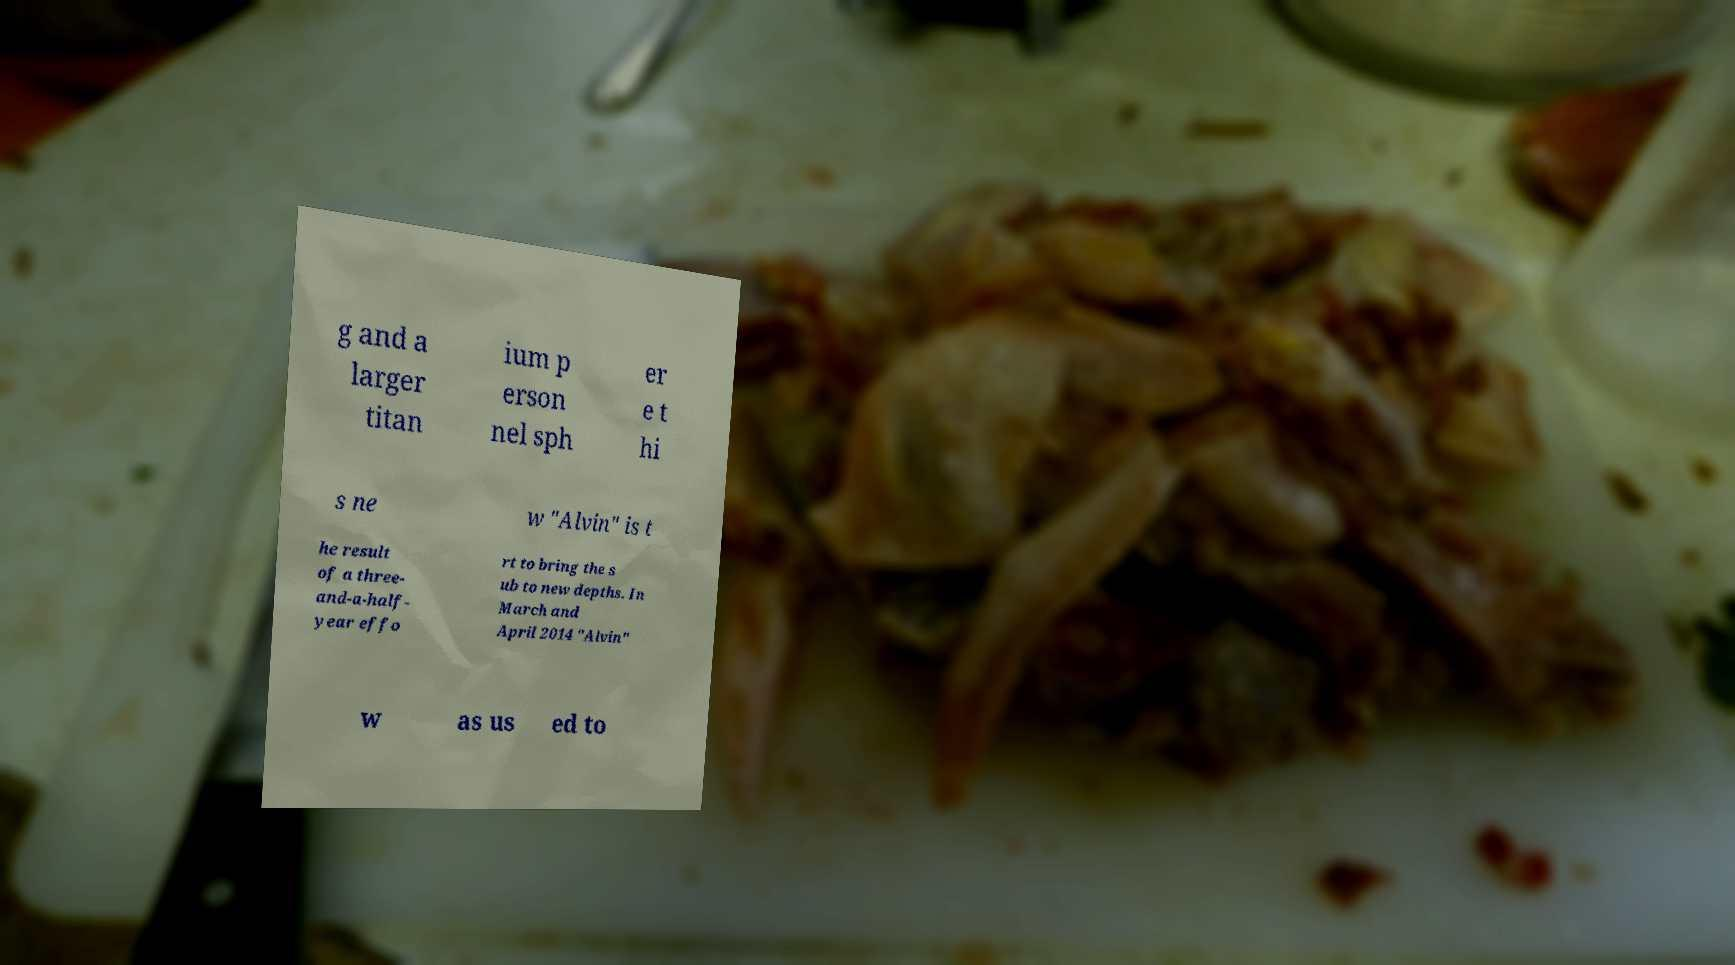Can you accurately transcribe the text from the provided image for me? g and a larger titan ium p erson nel sph er e t hi s ne w "Alvin" is t he result of a three- and-a-half- year effo rt to bring the s ub to new depths. In March and April 2014 "Alvin" w as us ed to 